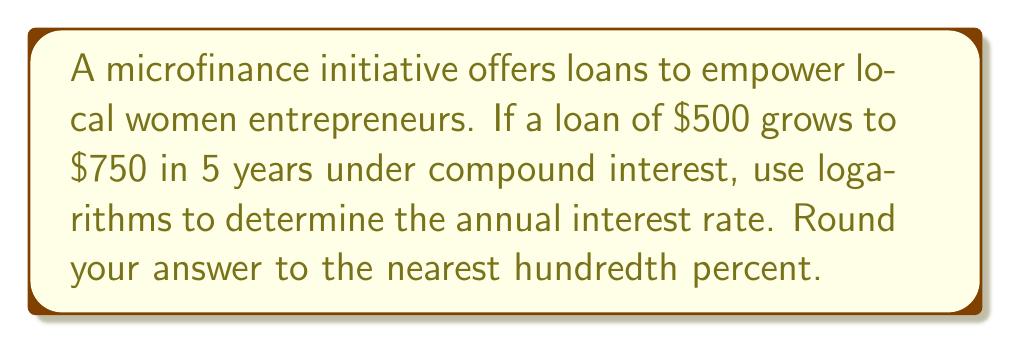Give your solution to this math problem. Let's approach this step-by-step using the compound interest formula and logarithms:

1) The compound interest formula is:
   $$A = P(1 + r)^t$$
   Where:
   $A$ = Final amount
   $P$ = Principal (initial investment)
   $r$ = Annual interest rate (in decimal form)
   $t$ = Time in years

2) We know:
   $A = 750$
   $P = 500$
   $t = 5$
   We need to solve for $r$.

3) Substituting the known values:
   $$750 = 500(1 + r)^5$$

4) Divide both sides by 500:
   $$\frac{750}{500} = (1 + r)^5$$
   $$1.5 = (1 + r)^5$$

5) Take the natural logarithm of both sides:
   $$\ln(1.5) = \ln((1 + r)^5)$$

6) Use the logarithm property $\ln(x^n) = n\ln(x)$:
   $$\ln(1.5) = 5\ln(1 + r)$$

7) Divide both sides by 5:
   $$\frac{\ln(1.5)}{5} = \ln(1 + r)$$

8) Take $e$ to the power of both sides:
   $$e^{\frac{\ln(1.5)}{5}} = e^{\ln(1 + r)} = 1 + r$$

9) Subtract 1 from both sides:
   $$e^{\frac{\ln(1.5)}{5}} - 1 = r$$

10) Calculate:
    $$r \approx 0.0845 = 8.45\%$$

Rounding to the nearest hundredth percent gives 8.45%.
Answer: 8.45% 